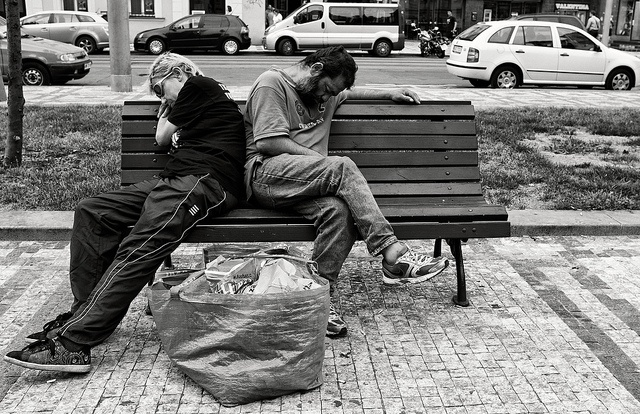Describe the objects in this image and their specific colors. I can see people in black, gray, darkgray, and lightgray tones, people in black, gray, darkgray, and lightgray tones, bench in black and gray tones, car in black, lightgray, darkgray, and gray tones, and car in black, lightgray, darkgray, and gray tones in this image. 